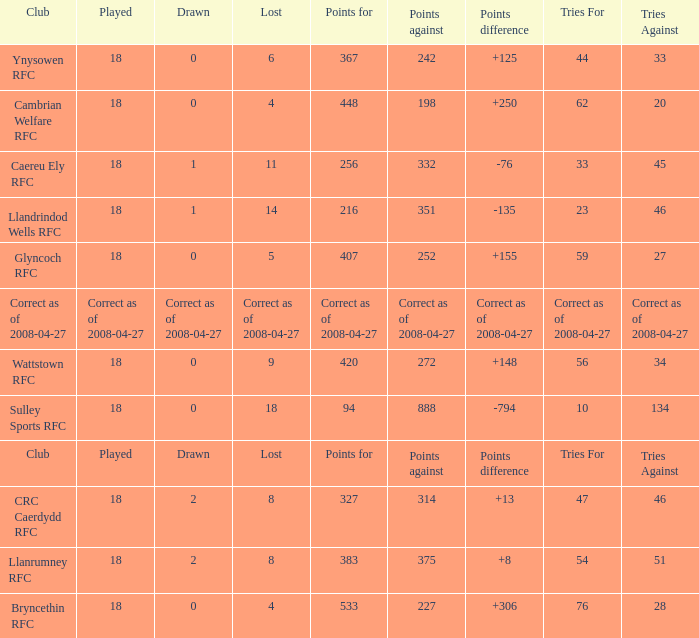What is the value of the item "Points" when the value of the item "Points against" is 272? 420.0. 